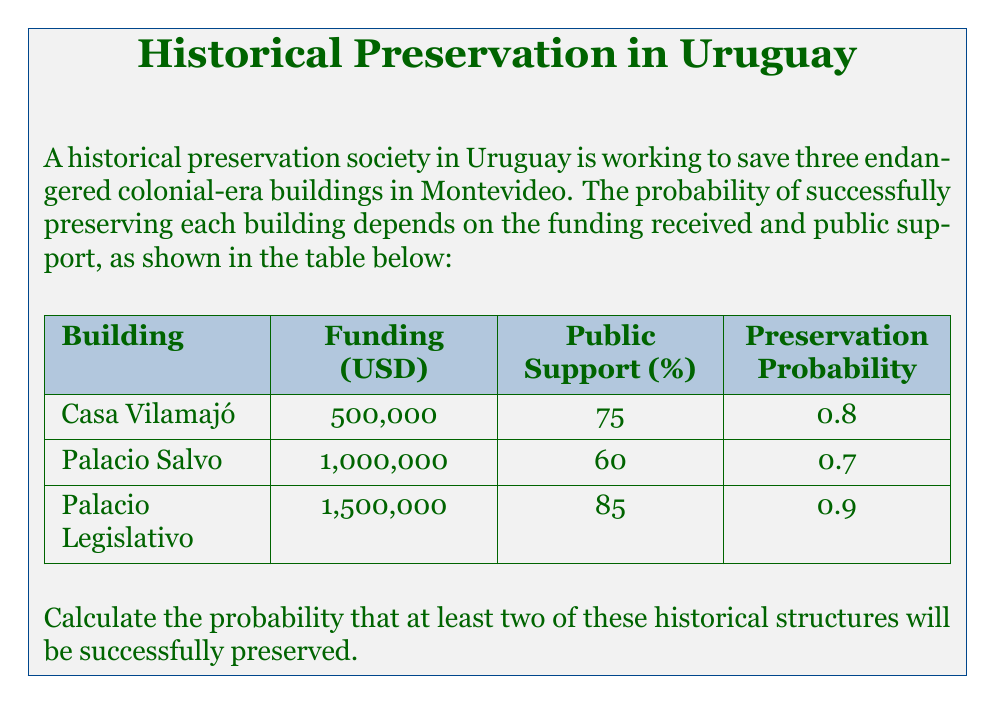Help me with this question. To solve this problem, we'll use the concept of complementary events and the binomial probability distribution.

Step 1: Let's define the success of preserving each building as independent events.

Step 2: Calculate the probability of preserving exactly 0 or 1 building, then subtract from 1 to get the probability of preserving at least 2 buildings.

Step 3: Use the binomial probability formula:

$$P(X = k) = \binom{n}{k} p^k (1-p)^{n-k}$$

Where:
$n$ = number of trials (3 buildings)
$k$ = number of successes
$p$ = probability of success for each trial

Step 4: Calculate the average probability of success:
$p = \frac{0.8 + 0.7 + 0.9}{3} = 0.8$

Step 5: Calculate the probability of preserving 0 buildings:
$$P(X = 0) = \binom{3}{0} (0.8)^0 (1-0.8)^{3-0} = 1 \cdot 1 \cdot 0.2^3 = 0.008$$

Step 6: Calculate the probability of preserving 1 building:
$$P(X = 1) = \binom{3}{1} (0.8)^1 (1-0.8)^{3-1} = 3 \cdot 0.8 \cdot 0.2^2 = 0.096$$

Step 7: Sum the probabilities of preserving 0 or 1 building:
$P(X \leq 1) = 0.008 + 0.096 = 0.104$

Step 8: Calculate the probability of preserving at least 2 buildings:
$P(X \geq 2) = 1 - P(X \leq 1) = 1 - 0.104 = 0.896$

Therefore, the probability of preserving at least two of the historical structures is 0.896 or 89.6%.
Answer: 0.896 